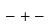<formula> <loc_0><loc_0><loc_500><loc_500>- + -</formula> 